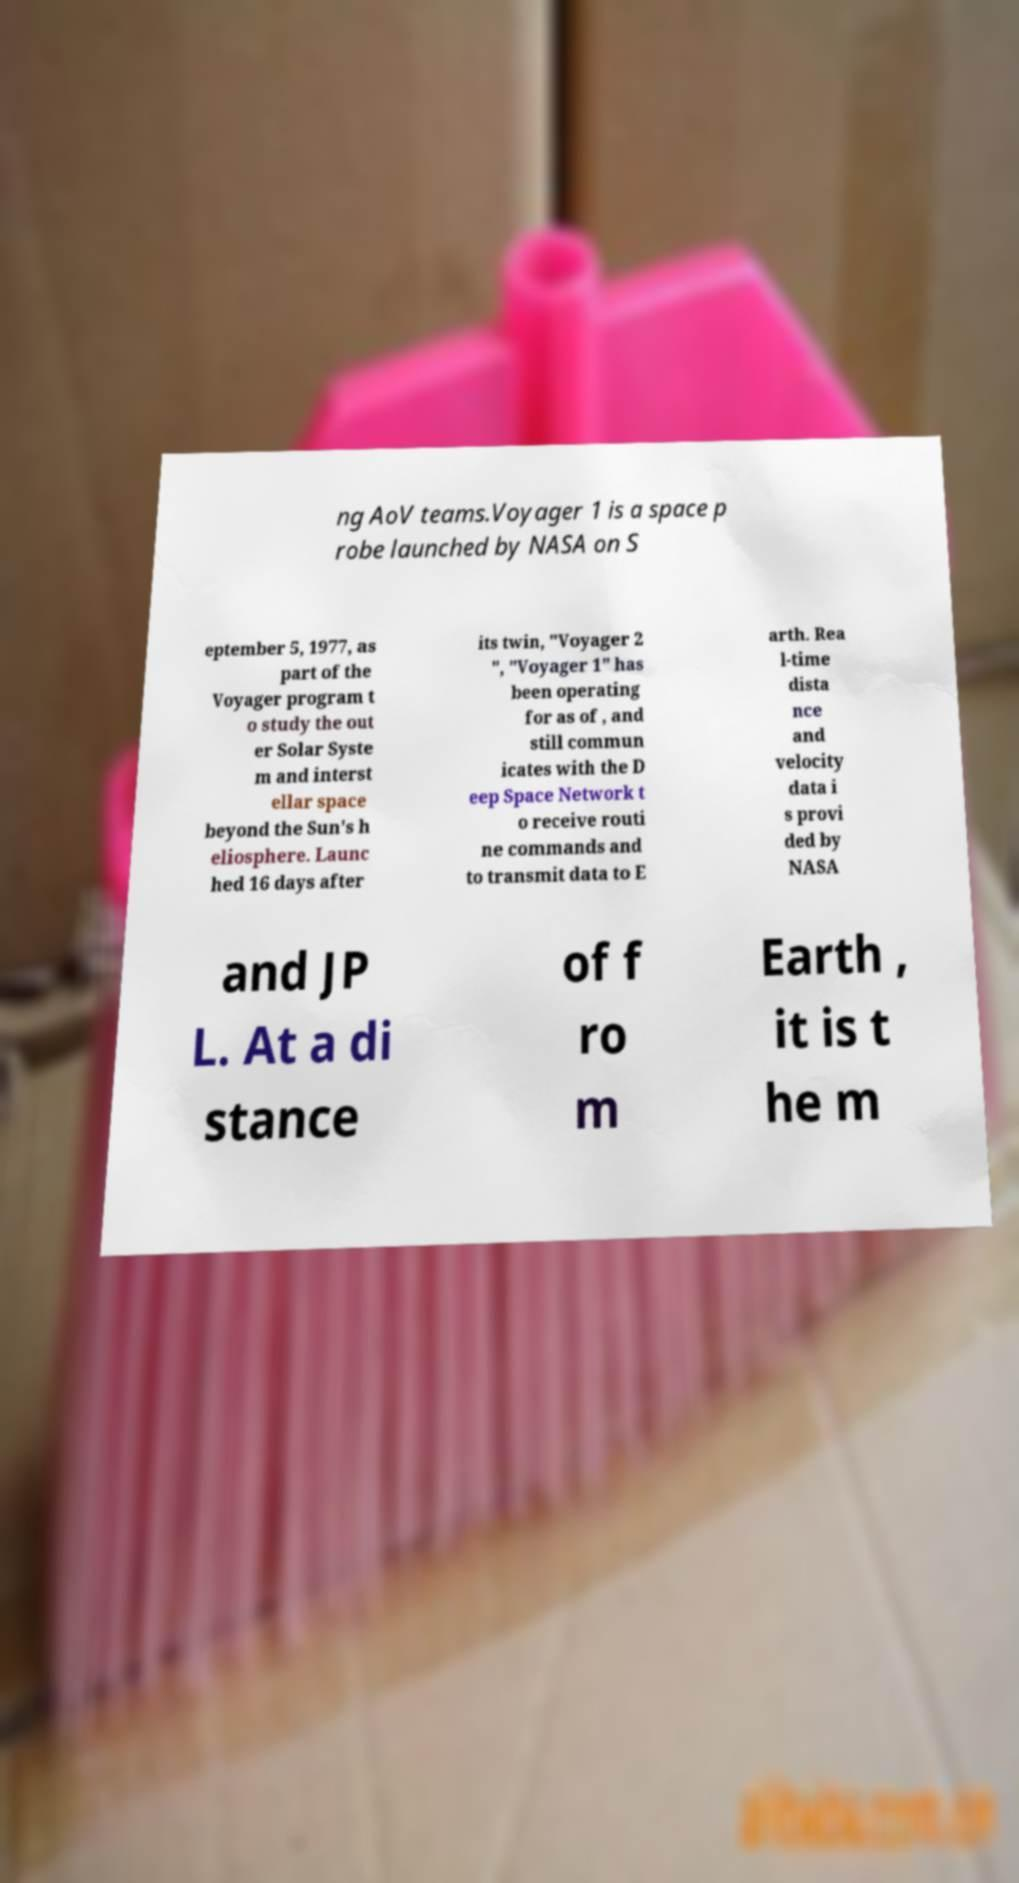Please identify and transcribe the text found in this image. ng AoV teams.Voyager 1 is a space p robe launched by NASA on S eptember 5, 1977, as part of the Voyager program t o study the out er Solar Syste m and interst ellar space beyond the Sun's h eliosphere. Launc hed 16 days after its twin, "Voyager 2 ", "Voyager 1" has been operating for as of , and still commun icates with the D eep Space Network t o receive routi ne commands and to transmit data to E arth. Rea l-time dista nce and velocity data i s provi ded by NASA and JP L. At a di stance of f ro m Earth , it is t he m 